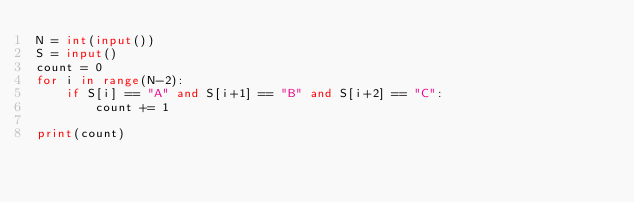<code> <loc_0><loc_0><loc_500><loc_500><_Python_>N = int(input())
S = input()
count = 0
for i in range(N-2):
    if S[i] == "A" and S[i+1] == "B" and S[i+2] == "C":
        count += 1

print(count)</code> 